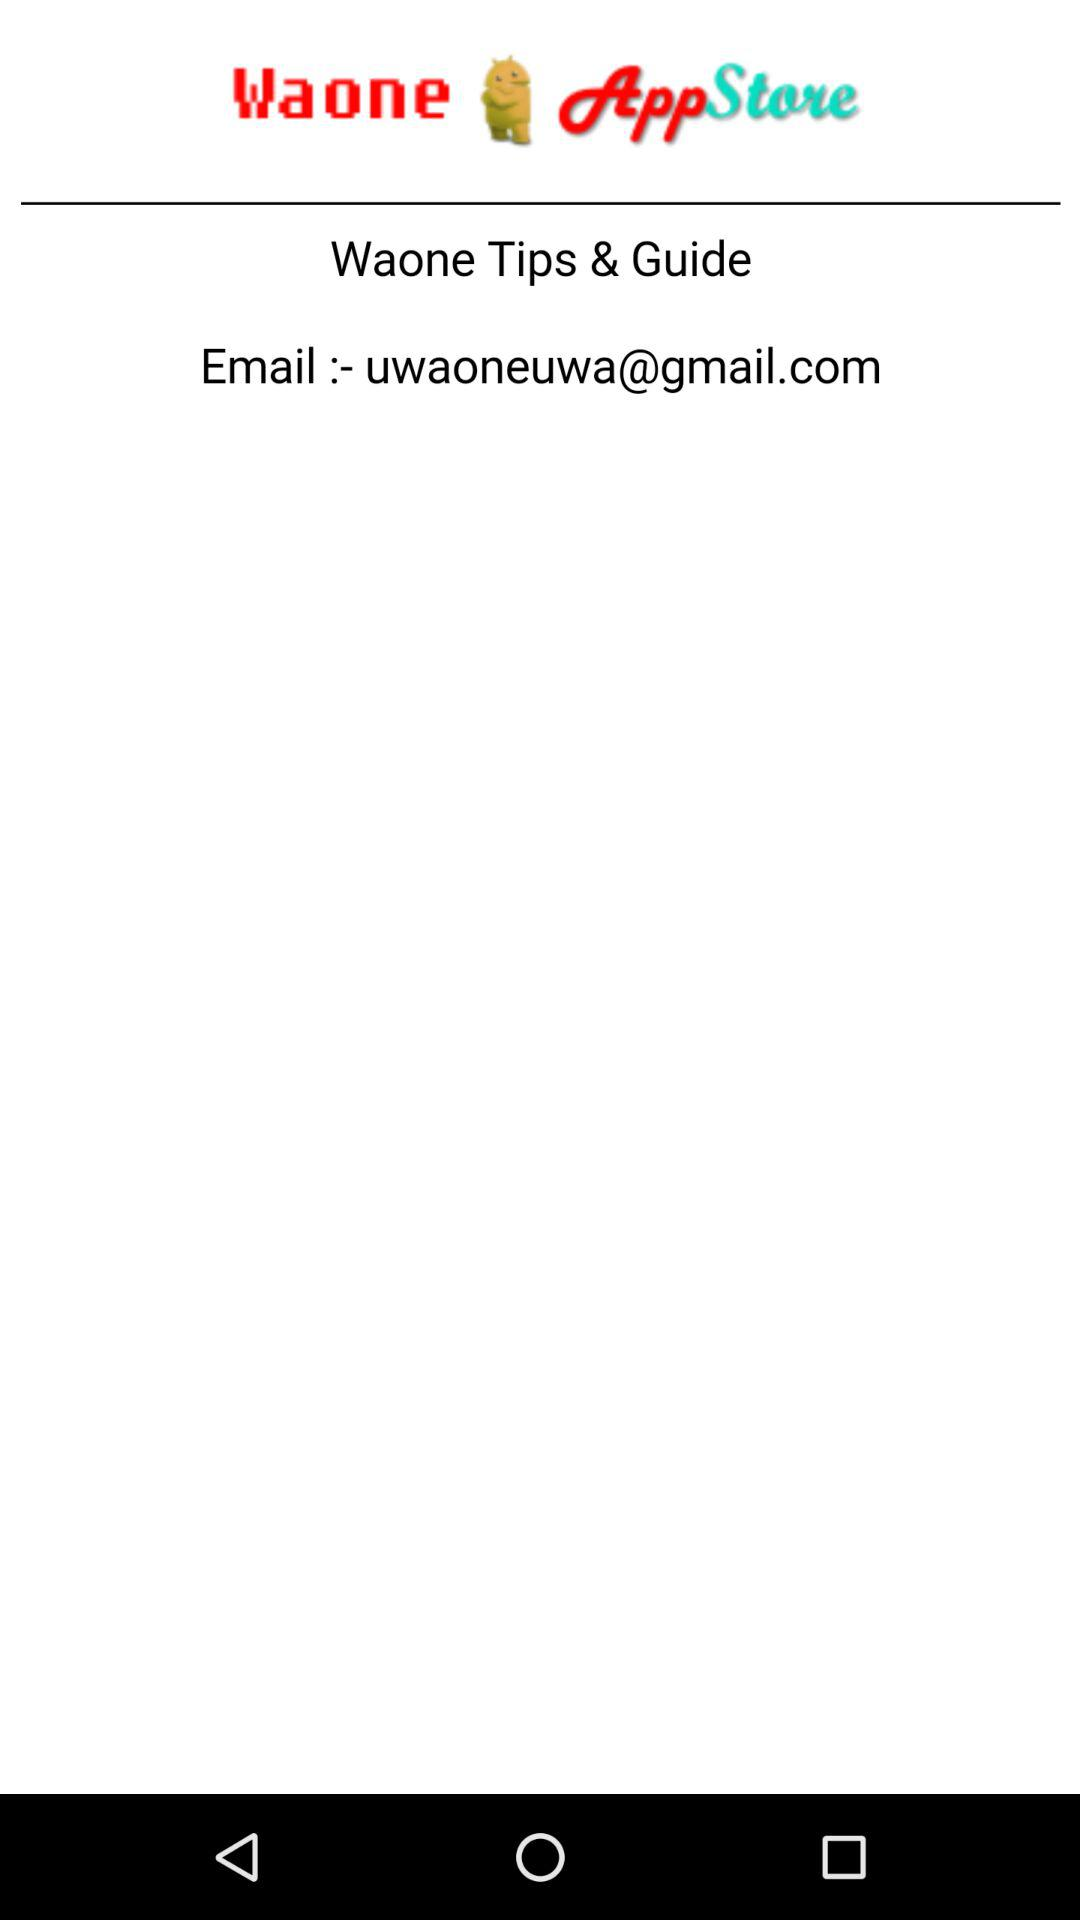How to pronounce the Application name?
When the provided information is insufficient, respond with <no answer>. <no answer> 